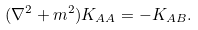<formula> <loc_0><loc_0><loc_500><loc_500>( \nabla ^ { 2 } + m ^ { 2 } ) K _ { A A } = - K _ { A B } .</formula> 